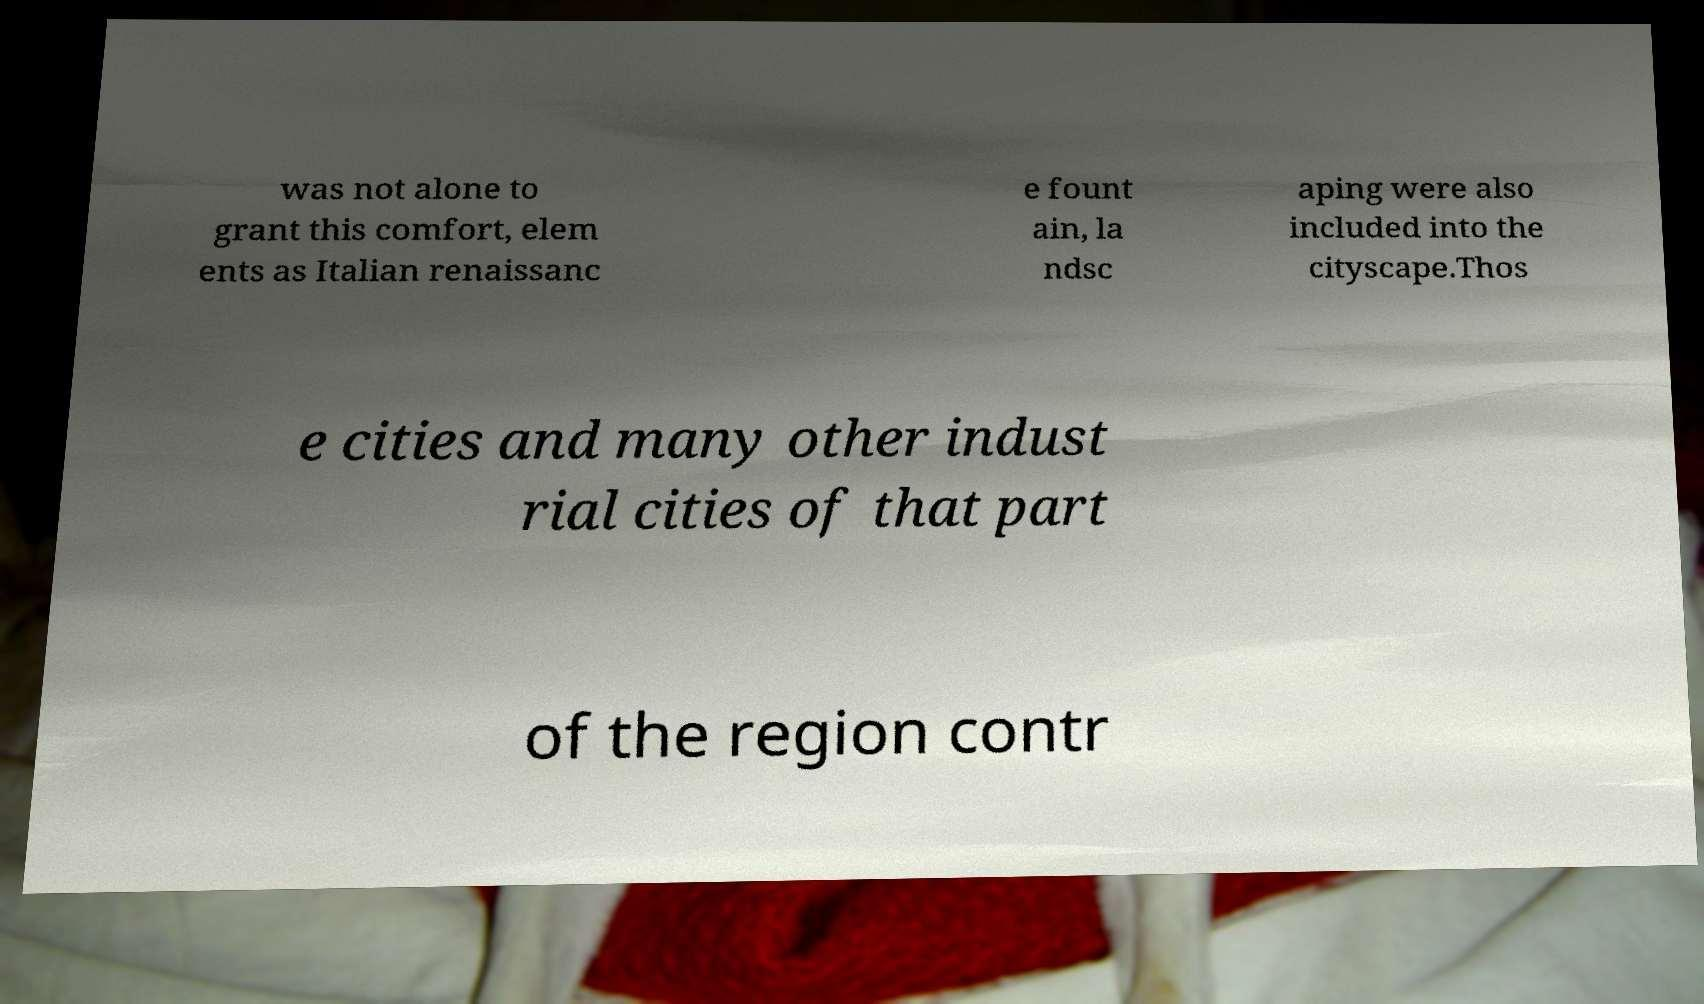Can you read and provide the text displayed in the image?This photo seems to have some interesting text. Can you extract and type it out for me? was not alone to grant this comfort, elem ents as Italian renaissanc e fount ain, la ndsc aping were also included into the cityscape.Thos e cities and many other indust rial cities of that part of the region contr 